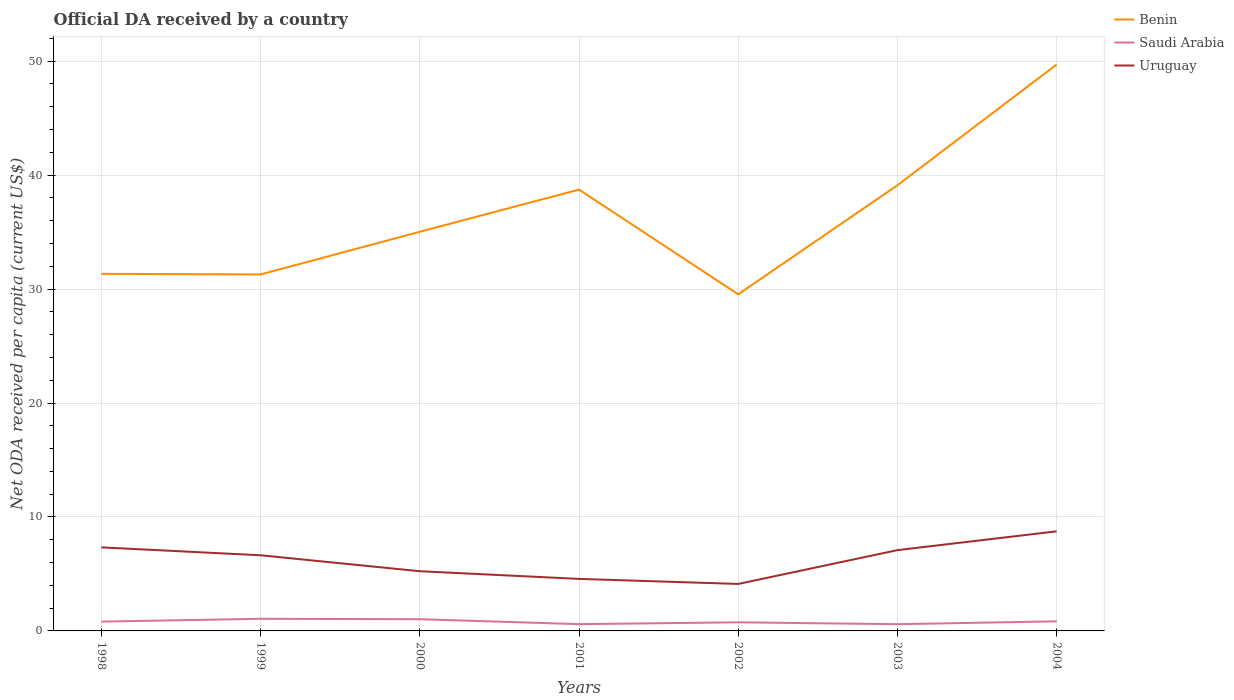Is the number of lines equal to the number of legend labels?
Offer a very short reply. Yes. Across all years, what is the maximum ODA received in in Uruguay?
Provide a short and direct response. 4.12. In which year was the ODA received in in Saudi Arabia maximum?
Give a very brief answer. 2003. What is the total ODA received in in Benin in the graph?
Provide a short and direct response. -7.77. What is the difference between the highest and the second highest ODA received in in Saudi Arabia?
Your answer should be very brief. 0.47. Is the ODA received in in Uruguay strictly greater than the ODA received in in Saudi Arabia over the years?
Provide a succinct answer. No. How many lines are there?
Your response must be concise. 3. How many years are there in the graph?
Ensure brevity in your answer.  7. Does the graph contain any zero values?
Your response must be concise. No. What is the title of the graph?
Keep it short and to the point. Official DA received by a country. Does "Italy" appear as one of the legend labels in the graph?
Your answer should be compact. No. What is the label or title of the Y-axis?
Provide a short and direct response. Net ODA received per capita (current US$). What is the Net ODA received per capita (current US$) in Benin in 1998?
Your response must be concise. 31.34. What is the Net ODA received per capita (current US$) of Saudi Arabia in 1998?
Your answer should be compact. 0.82. What is the Net ODA received per capita (current US$) of Uruguay in 1998?
Provide a succinct answer. 7.33. What is the Net ODA received per capita (current US$) of Benin in 1999?
Ensure brevity in your answer.  31.29. What is the Net ODA received per capita (current US$) of Saudi Arabia in 1999?
Keep it short and to the point. 1.06. What is the Net ODA received per capita (current US$) of Uruguay in 1999?
Make the answer very short. 6.64. What is the Net ODA received per capita (current US$) of Benin in 2000?
Ensure brevity in your answer.  35.03. What is the Net ODA received per capita (current US$) of Saudi Arabia in 2000?
Offer a very short reply. 1.03. What is the Net ODA received per capita (current US$) of Uruguay in 2000?
Give a very brief answer. 5.24. What is the Net ODA received per capita (current US$) of Benin in 2001?
Provide a short and direct response. 38.73. What is the Net ODA received per capita (current US$) in Saudi Arabia in 2001?
Provide a succinct answer. 0.6. What is the Net ODA received per capita (current US$) in Uruguay in 2001?
Provide a succinct answer. 4.57. What is the Net ODA received per capita (current US$) of Benin in 2002?
Your answer should be compact. 29.54. What is the Net ODA received per capita (current US$) of Saudi Arabia in 2002?
Your answer should be very brief. 0.76. What is the Net ODA received per capita (current US$) of Uruguay in 2002?
Offer a terse response. 4.12. What is the Net ODA received per capita (current US$) of Benin in 2003?
Offer a terse response. 39.11. What is the Net ODA received per capita (current US$) in Saudi Arabia in 2003?
Your answer should be compact. 0.59. What is the Net ODA received per capita (current US$) in Uruguay in 2003?
Your answer should be compact. 7.09. What is the Net ODA received per capita (current US$) of Benin in 2004?
Your response must be concise. 49.7. What is the Net ODA received per capita (current US$) of Saudi Arabia in 2004?
Your response must be concise. 0.84. What is the Net ODA received per capita (current US$) of Uruguay in 2004?
Give a very brief answer. 8.74. Across all years, what is the maximum Net ODA received per capita (current US$) in Benin?
Offer a very short reply. 49.7. Across all years, what is the maximum Net ODA received per capita (current US$) in Saudi Arabia?
Your answer should be very brief. 1.06. Across all years, what is the maximum Net ODA received per capita (current US$) in Uruguay?
Your answer should be compact. 8.74. Across all years, what is the minimum Net ODA received per capita (current US$) of Benin?
Provide a short and direct response. 29.54. Across all years, what is the minimum Net ODA received per capita (current US$) in Saudi Arabia?
Your response must be concise. 0.59. Across all years, what is the minimum Net ODA received per capita (current US$) of Uruguay?
Make the answer very short. 4.12. What is the total Net ODA received per capita (current US$) of Benin in the graph?
Provide a short and direct response. 254.74. What is the total Net ODA received per capita (current US$) in Saudi Arabia in the graph?
Ensure brevity in your answer.  5.69. What is the total Net ODA received per capita (current US$) in Uruguay in the graph?
Make the answer very short. 43.73. What is the difference between the Net ODA received per capita (current US$) in Benin in 1998 and that in 1999?
Offer a terse response. 0.05. What is the difference between the Net ODA received per capita (current US$) of Saudi Arabia in 1998 and that in 1999?
Make the answer very short. -0.25. What is the difference between the Net ODA received per capita (current US$) in Uruguay in 1998 and that in 1999?
Your answer should be compact. 0.69. What is the difference between the Net ODA received per capita (current US$) of Benin in 1998 and that in 2000?
Make the answer very short. -3.69. What is the difference between the Net ODA received per capita (current US$) in Saudi Arabia in 1998 and that in 2000?
Give a very brief answer. -0.21. What is the difference between the Net ODA received per capita (current US$) in Uruguay in 1998 and that in 2000?
Your answer should be very brief. 2.09. What is the difference between the Net ODA received per capita (current US$) in Benin in 1998 and that in 2001?
Keep it short and to the point. -7.39. What is the difference between the Net ODA received per capita (current US$) in Saudi Arabia in 1998 and that in 2001?
Provide a succinct answer. 0.22. What is the difference between the Net ODA received per capita (current US$) in Uruguay in 1998 and that in 2001?
Ensure brevity in your answer.  2.77. What is the difference between the Net ODA received per capita (current US$) in Benin in 1998 and that in 2002?
Provide a short and direct response. 1.8. What is the difference between the Net ODA received per capita (current US$) of Saudi Arabia in 1998 and that in 2002?
Offer a terse response. 0.06. What is the difference between the Net ODA received per capita (current US$) in Uruguay in 1998 and that in 2002?
Make the answer very short. 3.21. What is the difference between the Net ODA received per capita (current US$) of Benin in 1998 and that in 2003?
Give a very brief answer. -7.77. What is the difference between the Net ODA received per capita (current US$) of Saudi Arabia in 1998 and that in 2003?
Make the answer very short. 0.23. What is the difference between the Net ODA received per capita (current US$) in Uruguay in 1998 and that in 2003?
Offer a terse response. 0.24. What is the difference between the Net ODA received per capita (current US$) of Benin in 1998 and that in 2004?
Make the answer very short. -18.37. What is the difference between the Net ODA received per capita (current US$) of Saudi Arabia in 1998 and that in 2004?
Provide a succinct answer. -0.02. What is the difference between the Net ODA received per capita (current US$) in Uruguay in 1998 and that in 2004?
Keep it short and to the point. -1.41. What is the difference between the Net ODA received per capita (current US$) in Benin in 1999 and that in 2000?
Your answer should be very brief. -3.75. What is the difference between the Net ODA received per capita (current US$) in Saudi Arabia in 1999 and that in 2000?
Your answer should be very brief. 0.04. What is the difference between the Net ODA received per capita (current US$) of Uruguay in 1999 and that in 2000?
Ensure brevity in your answer.  1.4. What is the difference between the Net ODA received per capita (current US$) of Benin in 1999 and that in 2001?
Your answer should be compact. -7.45. What is the difference between the Net ODA received per capita (current US$) in Saudi Arabia in 1999 and that in 2001?
Provide a short and direct response. 0.47. What is the difference between the Net ODA received per capita (current US$) in Uruguay in 1999 and that in 2001?
Your answer should be very brief. 2.07. What is the difference between the Net ODA received per capita (current US$) in Benin in 1999 and that in 2002?
Ensure brevity in your answer.  1.74. What is the difference between the Net ODA received per capita (current US$) in Saudi Arabia in 1999 and that in 2002?
Offer a terse response. 0.31. What is the difference between the Net ODA received per capita (current US$) of Uruguay in 1999 and that in 2002?
Offer a terse response. 2.52. What is the difference between the Net ODA received per capita (current US$) in Benin in 1999 and that in 2003?
Offer a terse response. -7.83. What is the difference between the Net ODA received per capita (current US$) in Saudi Arabia in 1999 and that in 2003?
Keep it short and to the point. 0.47. What is the difference between the Net ODA received per capita (current US$) of Uruguay in 1999 and that in 2003?
Your answer should be compact. -0.45. What is the difference between the Net ODA received per capita (current US$) in Benin in 1999 and that in 2004?
Keep it short and to the point. -18.42. What is the difference between the Net ODA received per capita (current US$) in Saudi Arabia in 1999 and that in 2004?
Give a very brief answer. 0.22. What is the difference between the Net ODA received per capita (current US$) in Uruguay in 1999 and that in 2004?
Give a very brief answer. -2.1. What is the difference between the Net ODA received per capita (current US$) of Benin in 2000 and that in 2001?
Make the answer very short. -3.7. What is the difference between the Net ODA received per capita (current US$) of Saudi Arabia in 2000 and that in 2001?
Ensure brevity in your answer.  0.43. What is the difference between the Net ODA received per capita (current US$) in Uruguay in 2000 and that in 2001?
Give a very brief answer. 0.67. What is the difference between the Net ODA received per capita (current US$) in Benin in 2000 and that in 2002?
Give a very brief answer. 5.49. What is the difference between the Net ODA received per capita (current US$) of Saudi Arabia in 2000 and that in 2002?
Provide a succinct answer. 0.27. What is the difference between the Net ODA received per capita (current US$) of Uruguay in 2000 and that in 2002?
Your response must be concise. 1.12. What is the difference between the Net ODA received per capita (current US$) in Benin in 2000 and that in 2003?
Make the answer very short. -4.08. What is the difference between the Net ODA received per capita (current US$) in Saudi Arabia in 2000 and that in 2003?
Give a very brief answer. 0.44. What is the difference between the Net ODA received per capita (current US$) of Uruguay in 2000 and that in 2003?
Give a very brief answer. -1.85. What is the difference between the Net ODA received per capita (current US$) in Benin in 2000 and that in 2004?
Your answer should be compact. -14.67. What is the difference between the Net ODA received per capita (current US$) of Saudi Arabia in 2000 and that in 2004?
Keep it short and to the point. 0.19. What is the difference between the Net ODA received per capita (current US$) in Uruguay in 2000 and that in 2004?
Your answer should be compact. -3.5. What is the difference between the Net ODA received per capita (current US$) of Benin in 2001 and that in 2002?
Ensure brevity in your answer.  9.19. What is the difference between the Net ODA received per capita (current US$) of Saudi Arabia in 2001 and that in 2002?
Offer a terse response. -0.16. What is the difference between the Net ODA received per capita (current US$) in Uruguay in 2001 and that in 2002?
Offer a very short reply. 0.44. What is the difference between the Net ODA received per capita (current US$) of Benin in 2001 and that in 2003?
Offer a terse response. -0.38. What is the difference between the Net ODA received per capita (current US$) in Saudi Arabia in 2001 and that in 2003?
Provide a succinct answer. 0.01. What is the difference between the Net ODA received per capita (current US$) in Uruguay in 2001 and that in 2003?
Keep it short and to the point. -2.52. What is the difference between the Net ODA received per capita (current US$) in Benin in 2001 and that in 2004?
Your response must be concise. -10.97. What is the difference between the Net ODA received per capita (current US$) in Saudi Arabia in 2001 and that in 2004?
Provide a succinct answer. -0.25. What is the difference between the Net ODA received per capita (current US$) in Uruguay in 2001 and that in 2004?
Offer a terse response. -4.17. What is the difference between the Net ODA received per capita (current US$) in Benin in 2002 and that in 2003?
Keep it short and to the point. -9.57. What is the difference between the Net ODA received per capita (current US$) in Saudi Arabia in 2002 and that in 2003?
Provide a succinct answer. 0.17. What is the difference between the Net ODA received per capita (current US$) in Uruguay in 2002 and that in 2003?
Keep it short and to the point. -2.97. What is the difference between the Net ODA received per capita (current US$) of Benin in 2002 and that in 2004?
Make the answer very short. -20.16. What is the difference between the Net ODA received per capita (current US$) of Saudi Arabia in 2002 and that in 2004?
Your response must be concise. -0.09. What is the difference between the Net ODA received per capita (current US$) in Uruguay in 2002 and that in 2004?
Provide a succinct answer. -4.62. What is the difference between the Net ODA received per capita (current US$) of Benin in 2003 and that in 2004?
Make the answer very short. -10.59. What is the difference between the Net ODA received per capita (current US$) in Saudi Arabia in 2003 and that in 2004?
Provide a short and direct response. -0.25. What is the difference between the Net ODA received per capita (current US$) in Uruguay in 2003 and that in 2004?
Your answer should be very brief. -1.65. What is the difference between the Net ODA received per capita (current US$) of Benin in 1998 and the Net ODA received per capita (current US$) of Saudi Arabia in 1999?
Your answer should be compact. 30.27. What is the difference between the Net ODA received per capita (current US$) in Benin in 1998 and the Net ODA received per capita (current US$) in Uruguay in 1999?
Your answer should be very brief. 24.7. What is the difference between the Net ODA received per capita (current US$) in Saudi Arabia in 1998 and the Net ODA received per capita (current US$) in Uruguay in 1999?
Make the answer very short. -5.82. What is the difference between the Net ODA received per capita (current US$) of Benin in 1998 and the Net ODA received per capita (current US$) of Saudi Arabia in 2000?
Your response must be concise. 30.31. What is the difference between the Net ODA received per capita (current US$) of Benin in 1998 and the Net ODA received per capita (current US$) of Uruguay in 2000?
Ensure brevity in your answer.  26.1. What is the difference between the Net ODA received per capita (current US$) of Saudi Arabia in 1998 and the Net ODA received per capita (current US$) of Uruguay in 2000?
Provide a short and direct response. -4.42. What is the difference between the Net ODA received per capita (current US$) in Benin in 1998 and the Net ODA received per capita (current US$) in Saudi Arabia in 2001?
Make the answer very short. 30.74. What is the difference between the Net ODA received per capita (current US$) of Benin in 1998 and the Net ODA received per capita (current US$) of Uruguay in 2001?
Provide a succinct answer. 26.77. What is the difference between the Net ODA received per capita (current US$) in Saudi Arabia in 1998 and the Net ODA received per capita (current US$) in Uruguay in 2001?
Provide a short and direct response. -3.75. What is the difference between the Net ODA received per capita (current US$) in Benin in 1998 and the Net ODA received per capita (current US$) in Saudi Arabia in 2002?
Offer a terse response. 30.58. What is the difference between the Net ODA received per capita (current US$) of Benin in 1998 and the Net ODA received per capita (current US$) of Uruguay in 2002?
Provide a succinct answer. 27.21. What is the difference between the Net ODA received per capita (current US$) in Saudi Arabia in 1998 and the Net ODA received per capita (current US$) in Uruguay in 2002?
Offer a very short reply. -3.31. What is the difference between the Net ODA received per capita (current US$) in Benin in 1998 and the Net ODA received per capita (current US$) in Saudi Arabia in 2003?
Provide a short and direct response. 30.75. What is the difference between the Net ODA received per capita (current US$) of Benin in 1998 and the Net ODA received per capita (current US$) of Uruguay in 2003?
Provide a short and direct response. 24.25. What is the difference between the Net ODA received per capita (current US$) of Saudi Arabia in 1998 and the Net ODA received per capita (current US$) of Uruguay in 2003?
Your answer should be very brief. -6.27. What is the difference between the Net ODA received per capita (current US$) of Benin in 1998 and the Net ODA received per capita (current US$) of Saudi Arabia in 2004?
Offer a very short reply. 30.5. What is the difference between the Net ODA received per capita (current US$) of Benin in 1998 and the Net ODA received per capita (current US$) of Uruguay in 2004?
Your response must be concise. 22.6. What is the difference between the Net ODA received per capita (current US$) of Saudi Arabia in 1998 and the Net ODA received per capita (current US$) of Uruguay in 2004?
Your answer should be compact. -7.92. What is the difference between the Net ODA received per capita (current US$) of Benin in 1999 and the Net ODA received per capita (current US$) of Saudi Arabia in 2000?
Ensure brevity in your answer.  30.26. What is the difference between the Net ODA received per capita (current US$) of Benin in 1999 and the Net ODA received per capita (current US$) of Uruguay in 2000?
Offer a terse response. 26.05. What is the difference between the Net ODA received per capita (current US$) in Saudi Arabia in 1999 and the Net ODA received per capita (current US$) in Uruguay in 2000?
Provide a short and direct response. -4.18. What is the difference between the Net ODA received per capita (current US$) of Benin in 1999 and the Net ODA received per capita (current US$) of Saudi Arabia in 2001?
Ensure brevity in your answer.  30.69. What is the difference between the Net ODA received per capita (current US$) of Benin in 1999 and the Net ODA received per capita (current US$) of Uruguay in 2001?
Keep it short and to the point. 26.72. What is the difference between the Net ODA received per capita (current US$) in Saudi Arabia in 1999 and the Net ODA received per capita (current US$) in Uruguay in 2001?
Offer a terse response. -3.5. What is the difference between the Net ODA received per capita (current US$) in Benin in 1999 and the Net ODA received per capita (current US$) in Saudi Arabia in 2002?
Provide a succinct answer. 30.53. What is the difference between the Net ODA received per capita (current US$) of Benin in 1999 and the Net ODA received per capita (current US$) of Uruguay in 2002?
Keep it short and to the point. 27.16. What is the difference between the Net ODA received per capita (current US$) in Saudi Arabia in 1999 and the Net ODA received per capita (current US$) in Uruguay in 2002?
Keep it short and to the point. -3.06. What is the difference between the Net ODA received per capita (current US$) in Benin in 1999 and the Net ODA received per capita (current US$) in Saudi Arabia in 2003?
Give a very brief answer. 30.7. What is the difference between the Net ODA received per capita (current US$) of Benin in 1999 and the Net ODA received per capita (current US$) of Uruguay in 2003?
Provide a short and direct response. 24.2. What is the difference between the Net ODA received per capita (current US$) of Saudi Arabia in 1999 and the Net ODA received per capita (current US$) of Uruguay in 2003?
Offer a very short reply. -6.03. What is the difference between the Net ODA received per capita (current US$) of Benin in 1999 and the Net ODA received per capita (current US$) of Saudi Arabia in 2004?
Your answer should be compact. 30.44. What is the difference between the Net ODA received per capita (current US$) in Benin in 1999 and the Net ODA received per capita (current US$) in Uruguay in 2004?
Provide a succinct answer. 22.55. What is the difference between the Net ODA received per capita (current US$) of Saudi Arabia in 1999 and the Net ODA received per capita (current US$) of Uruguay in 2004?
Provide a succinct answer. -7.68. What is the difference between the Net ODA received per capita (current US$) of Benin in 2000 and the Net ODA received per capita (current US$) of Saudi Arabia in 2001?
Offer a terse response. 34.44. What is the difference between the Net ODA received per capita (current US$) of Benin in 2000 and the Net ODA received per capita (current US$) of Uruguay in 2001?
Your response must be concise. 30.47. What is the difference between the Net ODA received per capita (current US$) of Saudi Arabia in 2000 and the Net ODA received per capita (current US$) of Uruguay in 2001?
Provide a succinct answer. -3.54. What is the difference between the Net ODA received per capita (current US$) of Benin in 2000 and the Net ODA received per capita (current US$) of Saudi Arabia in 2002?
Offer a very short reply. 34.28. What is the difference between the Net ODA received per capita (current US$) in Benin in 2000 and the Net ODA received per capita (current US$) in Uruguay in 2002?
Offer a terse response. 30.91. What is the difference between the Net ODA received per capita (current US$) of Saudi Arabia in 2000 and the Net ODA received per capita (current US$) of Uruguay in 2002?
Make the answer very short. -3.1. What is the difference between the Net ODA received per capita (current US$) of Benin in 2000 and the Net ODA received per capita (current US$) of Saudi Arabia in 2003?
Your answer should be very brief. 34.44. What is the difference between the Net ODA received per capita (current US$) of Benin in 2000 and the Net ODA received per capita (current US$) of Uruguay in 2003?
Ensure brevity in your answer.  27.94. What is the difference between the Net ODA received per capita (current US$) of Saudi Arabia in 2000 and the Net ODA received per capita (current US$) of Uruguay in 2003?
Your response must be concise. -6.06. What is the difference between the Net ODA received per capita (current US$) in Benin in 2000 and the Net ODA received per capita (current US$) in Saudi Arabia in 2004?
Ensure brevity in your answer.  34.19. What is the difference between the Net ODA received per capita (current US$) of Benin in 2000 and the Net ODA received per capita (current US$) of Uruguay in 2004?
Provide a short and direct response. 26.29. What is the difference between the Net ODA received per capita (current US$) of Saudi Arabia in 2000 and the Net ODA received per capita (current US$) of Uruguay in 2004?
Keep it short and to the point. -7.71. What is the difference between the Net ODA received per capita (current US$) in Benin in 2001 and the Net ODA received per capita (current US$) in Saudi Arabia in 2002?
Provide a succinct answer. 37.98. What is the difference between the Net ODA received per capita (current US$) of Benin in 2001 and the Net ODA received per capita (current US$) of Uruguay in 2002?
Offer a terse response. 34.61. What is the difference between the Net ODA received per capita (current US$) in Saudi Arabia in 2001 and the Net ODA received per capita (current US$) in Uruguay in 2002?
Keep it short and to the point. -3.53. What is the difference between the Net ODA received per capita (current US$) in Benin in 2001 and the Net ODA received per capita (current US$) in Saudi Arabia in 2003?
Give a very brief answer. 38.14. What is the difference between the Net ODA received per capita (current US$) of Benin in 2001 and the Net ODA received per capita (current US$) of Uruguay in 2003?
Make the answer very short. 31.64. What is the difference between the Net ODA received per capita (current US$) in Saudi Arabia in 2001 and the Net ODA received per capita (current US$) in Uruguay in 2003?
Keep it short and to the point. -6.49. What is the difference between the Net ODA received per capita (current US$) of Benin in 2001 and the Net ODA received per capita (current US$) of Saudi Arabia in 2004?
Provide a short and direct response. 37.89. What is the difference between the Net ODA received per capita (current US$) in Benin in 2001 and the Net ODA received per capita (current US$) in Uruguay in 2004?
Your answer should be compact. 29.99. What is the difference between the Net ODA received per capita (current US$) of Saudi Arabia in 2001 and the Net ODA received per capita (current US$) of Uruguay in 2004?
Provide a succinct answer. -8.14. What is the difference between the Net ODA received per capita (current US$) of Benin in 2002 and the Net ODA received per capita (current US$) of Saudi Arabia in 2003?
Provide a short and direct response. 28.95. What is the difference between the Net ODA received per capita (current US$) in Benin in 2002 and the Net ODA received per capita (current US$) in Uruguay in 2003?
Your answer should be very brief. 22.45. What is the difference between the Net ODA received per capita (current US$) in Saudi Arabia in 2002 and the Net ODA received per capita (current US$) in Uruguay in 2003?
Your response must be concise. -6.33. What is the difference between the Net ODA received per capita (current US$) in Benin in 2002 and the Net ODA received per capita (current US$) in Saudi Arabia in 2004?
Offer a terse response. 28.7. What is the difference between the Net ODA received per capita (current US$) in Benin in 2002 and the Net ODA received per capita (current US$) in Uruguay in 2004?
Provide a succinct answer. 20.8. What is the difference between the Net ODA received per capita (current US$) of Saudi Arabia in 2002 and the Net ODA received per capita (current US$) of Uruguay in 2004?
Give a very brief answer. -7.98. What is the difference between the Net ODA received per capita (current US$) in Benin in 2003 and the Net ODA received per capita (current US$) in Saudi Arabia in 2004?
Your response must be concise. 38.27. What is the difference between the Net ODA received per capita (current US$) in Benin in 2003 and the Net ODA received per capita (current US$) in Uruguay in 2004?
Your answer should be very brief. 30.37. What is the difference between the Net ODA received per capita (current US$) in Saudi Arabia in 2003 and the Net ODA received per capita (current US$) in Uruguay in 2004?
Offer a terse response. -8.15. What is the average Net ODA received per capita (current US$) in Benin per year?
Provide a succinct answer. 36.39. What is the average Net ODA received per capita (current US$) in Saudi Arabia per year?
Your answer should be compact. 0.81. What is the average Net ODA received per capita (current US$) of Uruguay per year?
Keep it short and to the point. 6.25. In the year 1998, what is the difference between the Net ODA received per capita (current US$) of Benin and Net ODA received per capita (current US$) of Saudi Arabia?
Your answer should be compact. 30.52. In the year 1998, what is the difference between the Net ODA received per capita (current US$) of Benin and Net ODA received per capita (current US$) of Uruguay?
Your response must be concise. 24. In the year 1998, what is the difference between the Net ODA received per capita (current US$) in Saudi Arabia and Net ODA received per capita (current US$) in Uruguay?
Your response must be concise. -6.52. In the year 1999, what is the difference between the Net ODA received per capita (current US$) in Benin and Net ODA received per capita (current US$) in Saudi Arabia?
Your answer should be very brief. 30.22. In the year 1999, what is the difference between the Net ODA received per capita (current US$) of Benin and Net ODA received per capita (current US$) of Uruguay?
Offer a very short reply. 24.65. In the year 1999, what is the difference between the Net ODA received per capita (current US$) in Saudi Arabia and Net ODA received per capita (current US$) in Uruguay?
Your answer should be compact. -5.58. In the year 2000, what is the difference between the Net ODA received per capita (current US$) of Benin and Net ODA received per capita (current US$) of Saudi Arabia?
Keep it short and to the point. 34.01. In the year 2000, what is the difference between the Net ODA received per capita (current US$) of Benin and Net ODA received per capita (current US$) of Uruguay?
Provide a short and direct response. 29.79. In the year 2000, what is the difference between the Net ODA received per capita (current US$) in Saudi Arabia and Net ODA received per capita (current US$) in Uruguay?
Offer a very short reply. -4.21. In the year 2001, what is the difference between the Net ODA received per capita (current US$) in Benin and Net ODA received per capita (current US$) in Saudi Arabia?
Your answer should be compact. 38.14. In the year 2001, what is the difference between the Net ODA received per capita (current US$) of Benin and Net ODA received per capita (current US$) of Uruguay?
Your answer should be very brief. 34.17. In the year 2001, what is the difference between the Net ODA received per capita (current US$) of Saudi Arabia and Net ODA received per capita (current US$) of Uruguay?
Your answer should be compact. -3.97. In the year 2002, what is the difference between the Net ODA received per capita (current US$) of Benin and Net ODA received per capita (current US$) of Saudi Arabia?
Provide a short and direct response. 28.79. In the year 2002, what is the difference between the Net ODA received per capita (current US$) of Benin and Net ODA received per capita (current US$) of Uruguay?
Keep it short and to the point. 25.42. In the year 2002, what is the difference between the Net ODA received per capita (current US$) of Saudi Arabia and Net ODA received per capita (current US$) of Uruguay?
Provide a short and direct response. -3.37. In the year 2003, what is the difference between the Net ODA received per capita (current US$) of Benin and Net ODA received per capita (current US$) of Saudi Arabia?
Your answer should be very brief. 38.52. In the year 2003, what is the difference between the Net ODA received per capita (current US$) in Benin and Net ODA received per capita (current US$) in Uruguay?
Make the answer very short. 32.02. In the year 2003, what is the difference between the Net ODA received per capita (current US$) in Saudi Arabia and Net ODA received per capita (current US$) in Uruguay?
Make the answer very short. -6.5. In the year 2004, what is the difference between the Net ODA received per capita (current US$) in Benin and Net ODA received per capita (current US$) in Saudi Arabia?
Make the answer very short. 48.86. In the year 2004, what is the difference between the Net ODA received per capita (current US$) of Benin and Net ODA received per capita (current US$) of Uruguay?
Ensure brevity in your answer.  40.97. In the year 2004, what is the difference between the Net ODA received per capita (current US$) of Saudi Arabia and Net ODA received per capita (current US$) of Uruguay?
Provide a short and direct response. -7.9. What is the ratio of the Net ODA received per capita (current US$) in Saudi Arabia in 1998 to that in 1999?
Give a very brief answer. 0.77. What is the ratio of the Net ODA received per capita (current US$) in Uruguay in 1998 to that in 1999?
Make the answer very short. 1.1. What is the ratio of the Net ODA received per capita (current US$) of Benin in 1998 to that in 2000?
Give a very brief answer. 0.89. What is the ratio of the Net ODA received per capita (current US$) of Saudi Arabia in 1998 to that in 2000?
Give a very brief answer. 0.8. What is the ratio of the Net ODA received per capita (current US$) in Uruguay in 1998 to that in 2000?
Offer a terse response. 1.4. What is the ratio of the Net ODA received per capita (current US$) of Benin in 1998 to that in 2001?
Provide a succinct answer. 0.81. What is the ratio of the Net ODA received per capita (current US$) of Saudi Arabia in 1998 to that in 2001?
Keep it short and to the point. 1.37. What is the ratio of the Net ODA received per capita (current US$) of Uruguay in 1998 to that in 2001?
Offer a very short reply. 1.61. What is the ratio of the Net ODA received per capita (current US$) in Benin in 1998 to that in 2002?
Keep it short and to the point. 1.06. What is the ratio of the Net ODA received per capita (current US$) in Saudi Arabia in 1998 to that in 2002?
Offer a very short reply. 1.08. What is the ratio of the Net ODA received per capita (current US$) in Uruguay in 1998 to that in 2002?
Provide a short and direct response. 1.78. What is the ratio of the Net ODA received per capita (current US$) in Benin in 1998 to that in 2003?
Give a very brief answer. 0.8. What is the ratio of the Net ODA received per capita (current US$) in Saudi Arabia in 1998 to that in 2003?
Offer a very short reply. 1.38. What is the ratio of the Net ODA received per capita (current US$) in Uruguay in 1998 to that in 2003?
Give a very brief answer. 1.03. What is the ratio of the Net ODA received per capita (current US$) of Benin in 1998 to that in 2004?
Ensure brevity in your answer.  0.63. What is the ratio of the Net ODA received per capita (current US$) of Saudi Arabia in 1998 to that in 2004?
Give a very brief answer. 0.97. What is the ratio of the Net ODA received per capita (current US$) of Uruguay in 1998 to that in 2004?
Offer a very short reply. 0.84. What is the ratio of the Net ODA received per capita (current US$) in Benin in 1999 to that in 2000?
Ensure brevity in your answer.  0.89. What is the ratio of the Net ODA received per capita (current US$) in Saudi Arabia in 1999 to that in 2000?
Provide a short and direct response. 1.04. What is the ratio of the Net ODA received per capita (current US$) of Uruguay in 1999 to that in 2000?
Make the answer very short. 1.27. What is the ratio of the Net ODA received per capita (current US$) of Benin in 1999 to that in 2001?
Your response must be concise. 0.81. What is the ratio of the Net ODA received per capita (current US$) in Saudi Arabia in 1999 to that in 2001?
Ensure brevity in your answer.  1.79. What is the ratio of the Net ODA received per capita (current US$) in Uruguay in 1999 to that in 2001?
Your answer should be very brief. 1.45. What is the ratio of the Net ODA received per capita (current US$) of Benin in 1999 to that in 2002?
Give a very brief answer. 1.06. What is the ratio of the Net ODA received per capita (current US$) of Saudi Arabia in 1999 to that in 2002?
Your response must be concise. 1.41. What is the ratio of the Net ODA received per capita (current US$) of Uruguay in 1999 to that in 2002?
Your answer should be very brief. 1.61. What is the ratio of the Net ODA received per capita (current US$) in Benin in 1999 to that in 2003?
Your answer should be very brief. 0.8. What is the ratio of the Net ODA received per capita (current US$) in Saudi Arabia in 1999 to that in 2003?
Offer a very short reply. 1.8. What is the ratio of the Net ODA received per capita (current US$) of Uruguay in 1999 to that in 2003?
Provide a succinct answer. 0.94. What is the ratio of the Net ODA received per capita (current US$) in Benin in 1999 to that in 2004?
Provide a succinct answer. 0.63. What is the ratio of the Net ODA received per capita (current US$) of Saudi Arabia in 1999 to that in 2004?
Your response must be concise. 1.26. What is the ratio of the Net ODA received per capita (current US$) in Uruguay in 1999 to that in 2004?
Make the answer very short. 0.76. What is the ratio of the Net ODA received per capita (current US$) in Benin in 2000 to that in 2001?
Provide a short and direct response. 0.9. What is the ratio of the Net ODA received per capita (current US$) in Saudi Arabia in 2000 to that in 2001?
Provide a short and direct response. 1.72. What is the ratio of the Net ODA received per capita (current US$) of Uruguay in 2000 to that in 2001?
Ensure brevity in your answer.  1.15. What is the ratio of the Net ODA received per capita (current US$) in Benin in 2000 to that in 2002?
Provide a short and direct response. 1.19. What is the ratio of the Net ODA received per capita (current US$) in Saudi Arabia in 2000 to that in 2002?
Make the answer very short. 1.36. What is the ratio of the Net ODA received per capita (current US$) of Uruguay in 2000 to that in 2002?
Make the answer very short. 1.27. What is the ratio of the Net ODA received per capita (current US$) of Benin in 2000 to that in 2003?
Your response must be concise. 0.9. What is the ratio of the Net ODA received per capita (current US$) in Saudi Arabia in 2000 to that in 2003?
Your answer should be very brief. 1.74. What is the ratio of the Net ODA received per capita (current US$) in Uruguay in 2000 to that in 2003?
Provide a short and direct response. 0.74. What is the ratio of the Net ODA received per capita (current US$) of Benin in 2000 to that in 2004?
Your answer should be very brief. 0.7. What is the ratio of the Net ODA received per capita (current US$) in Saudi Arabia in 2000 to that in 2004?
Make the answer very short. 1.22. What is the ratio of the Net ODA received per capita (current US$) in Uruguay in 2000 to that in 2004?
Give a very brief answer. 0.6. What is the ratio of the Net ODA received per capita (current US$) in Benin in 2001 to that in 2002?
Provide a short and direct response. 1.31. What is the ratio of the Net ODA received per capita (current US$) of Saudi Arabia in 2001 to that in 2002?
Your answer should be compact. 0.79. What is the ratio of the Net ODA received per capita (current US$) of Uruguay in 2001 to that in 2002?
Your response must be concise. 1.11. What is the ratio of the Net ODA received per capita (current US$) in Benin in 2001 to that in 2003?
Provide a short and direct response. 0.99. What is the ratio of the Net ODA received per capita (current US$) in Saudi Arabia in 2001 to that in 2003?
Keep it short and to the point. 1.01. What is the ratio of the Net ODA received per capita (current US$) in Uruguay in 2001 to that in 2003?
Offer a terse response. 0.64. What is the ratio of the Net ODA received per capita (current US$) of Benin in 2001 to that in 2004?
Ensure brevity in your answer.  0.78. What is the ratio of the Net ODA received per capita (current US$) of Saudi Arabia in 2001 to that in 2004?
Make the answer very short. 0.71. What is the ratio of the Net ODA received per capita (current US$) of Uruguay in 2001 to that in 2004?
Provide a short and direct response. 0.52. What is the ratio of the Net ODA received per capita (current US$) in Benin in 2002 to that in 2003?
Offer a terse response. 0.76. What is the ratio of the Net ODA received per capita (current US$) of Saudi Arabia in 2002 to that in 2003?
Provide a succinct answer. 1.28. What is the ratio of the Net ODA received per capita (current US$) of Uruguay in 2002 to that in 2003?
Provide a short and direct response. 0.58. What is the ratio of the Net ODA received per capita (current US$) of Benin in 2002 to that in 2004?
Your response must be concise. 0.59. What is the ratio of the Net ODA received per capita (current US$) of Saudi Arabia in 2002 to that in 2004?
Keep it short and to the point. 0.9. What is the ratio of the Net ODA received per capita (current US$) in Uruguay in 2002 to that in 2004?
Your answer should be compact. 0.47. What is the ratio of the Net ODA received per capita (current US$) in Benin in 2003 to that in 2004?
Offer a terse response. 0.79. What is the ratio of the Net ODA received per capita (current US$) of Saudi Arabia in 2003 to that in 2004?
Provide a short and direct response. 0.7. What is the ratio of the Net ODA received per capita (current US$) of Uruguay in 2003 to that in 2004?
Your answer should be very brief. 0.81. What is the difference between the highest and the second highest Net ODA received per capita (current US$) of Benin?
Provide a short and direct response. 10.59. What is the difference between the highest and the second highest Net ODA received per capita (current US$) in Saudi Arabia?
Your response must be concise. 0.04. What is the difference between the highest and the second highest Net ODA received per capita (current US$) of Uruguay?
Your answer should be very brief. 1.41. What is the difference between the highest and the lowest Net ODA received per capita (current US$) in Benin?
Provide a succinct answer. 20.16. What is the difference between the highest and the lowest Net ODA received per capita (current US$) in Saudi Arabia?
Your answer should be very brief. 0.47. What is the difference between the highest and the lowest Net ODA received per capita (current US$) of Uruguay?
Your answer should be very brief. 4.62. 